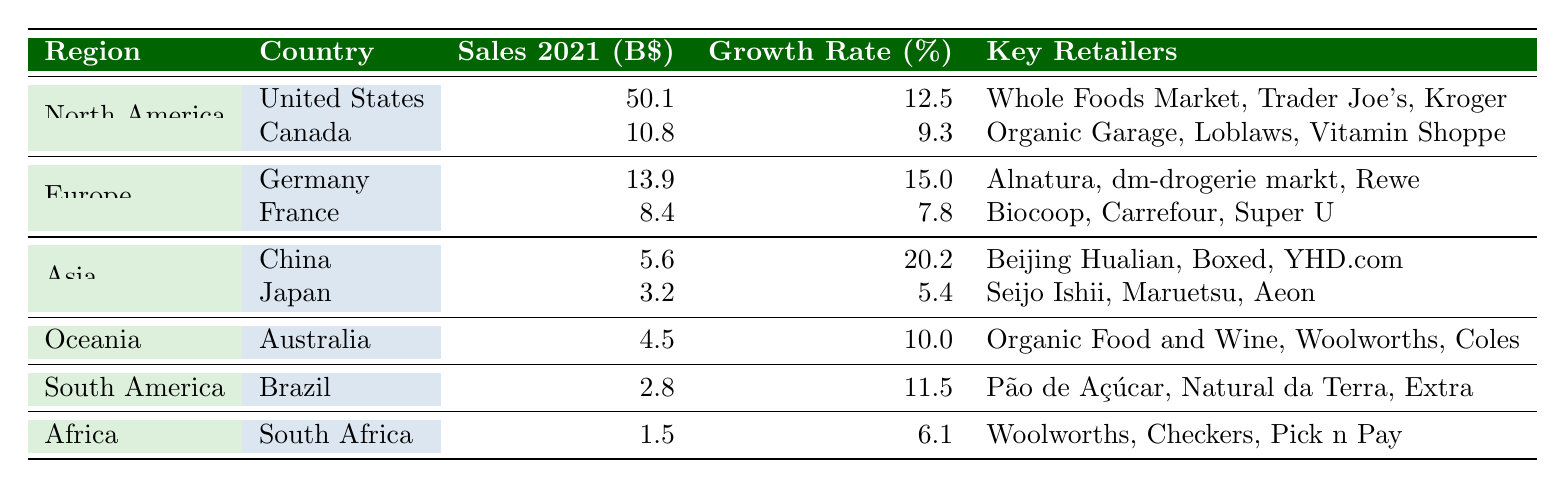What is the total sales for organic food in North America in 2021? The sales figures for North America are 50.1 billion dollars from the United States and 10.8 billion dollars from Canada. To find the total, we add these two numbers: 50.1 + 10.8 = 60.9 billion dollars.
Answer: 60.9 billion dollars Which country had the highest growth rate in organic food sales in 2021? We can compare the growth rates provided for all countries. The rates are: United States (12.5%), Canada (9.3%), Germany (15.0%), France (7.8%), China (20.2%), Japan (5.4%), Australia (10.0%), Brazil (11.5%), and South Africa (6.1%). The highest growth rate is in China at 20.2%.
Answer: China True or False: Organic food sales in South America were higher than in Africa in 2021. The sales figures are as follows: Brazil in South America had sales of 2.8 billion dollars, while South Africa in Africa had sales of 1.5 billion dollars. Since 2.8 is greater than 1.5, the statement is true.
Answer: True What is the average growth rate of organic food sales across all regions in 2021? We first collect all the growth rates: 12.5, 9.3, 15.0, 7.8, 20.2, 5.4, 10.0, 11.5, and 6.1 (total 9 values). We add them together: 12.5 + 9.3 + 15.0 + 7.8 + 20.2 + 5.4 + 10.0 + 11.5 + 6.1 = 96.8. Then, divide by the number of countries, which is 9: 96.8 / 9 ≈ 10.76%.
Answer: 10.76% Which region had the lowest sales in organic food for 2021? By reviewing the sales figures, North America reports 60.9 billion, Europe reports 22.3 billion (13.9 + 8.4), Asia reports 8.8 billion (5.6 + 3.2), Oceania reports 4.5 billion, South America reports 2.8 billion, and Africa reports 1.5 billion. South Africa has the lowest sales at 1.5 billion.
Answer: Africa 